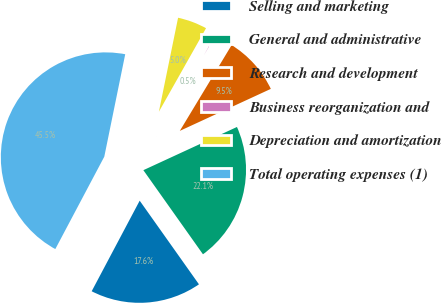<chart> <loc_0><loc_0><loc_500><loc_500><pie_chart><fcel>Selling and marketing<fcel>General and administrative<fcel>Research and development<fcel>Business reorganization and<fcel>Depreciation and amortization<fcel>Total operating expenses (1)<nl><fcel>17.57%<fcel>22.07%<fcel>9.47%<fcel>0.47%<fcel>4.97%<fcel>45.45%<nl></chart> 